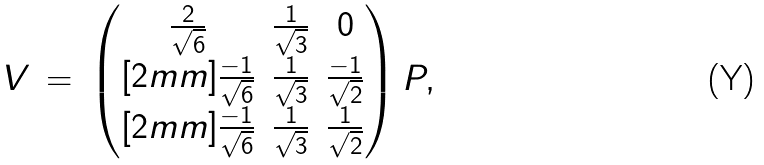Convert formula to latex. <formula><loc_0><loc_0><loc_500><loc_500>V \, = \, \begin{pmatrix} \frac { 2 } { \sqrt { 6 } } & \frac { 1 } { \sqrt { 3 } } & 0 \\ [ 2 m m ] \frac { - 1 } { \sqrt { 6 } } & \frac { 1 } { \sqrt { 3 } } & \frac { - 1 } { \sqrt { 2 } } \\ [ 2 m m ] \frac { - 1 } { \sqrt { 6 } } & \frac { 1 } { \sqrt { 3 } } & \frac { 1 } { \sqrt { 2 } } \end{pmatrix} P ,</formula> 